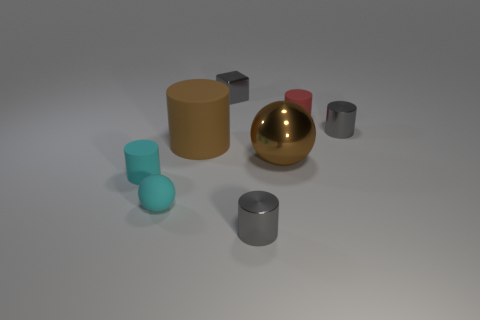The thing that is the same color as the large rubber cylinder is what shape?
Provide a short and direct response. Sphere. There is a brown thing to the left of the tiny shiny thing that is in front of the tiny sphere; is there a large cylinder to the right of it?
Make the answer very short. No. Are there any metal objects of the same size as the cyan cylinder?
Make the answer very short. Yes. There is a cyan matte object in front of the cyan matte cylinder; what is its size?
Offer a terse response. Small. The metal cylinder that is in front of the big brown object on the left side of the gray metallic cube to the left of the red rubber object is what color?
Offer a very short reply. Gray. There is a tiny matte cylinder that is on the right side of the cylinder on the left side of the small cyan ball; what is its color?
Your response must be concise. Red. Is the number of brown cylinders right of the metal cube greater than the number of brown things that are right of the big brown cylinder?
Make the answer very short. No. Is the material of the cylinder that is on the left side of the small sphere the same as the sphere that is right of the big cylinder?
Provide a succinct answer. No. Are there any tiny cyan cylinders behind the metal sphere?
Provide a succinct answer. No. How many purple things are either large metallic balls or small metal cubes?
Give a very brief answer. 0. 